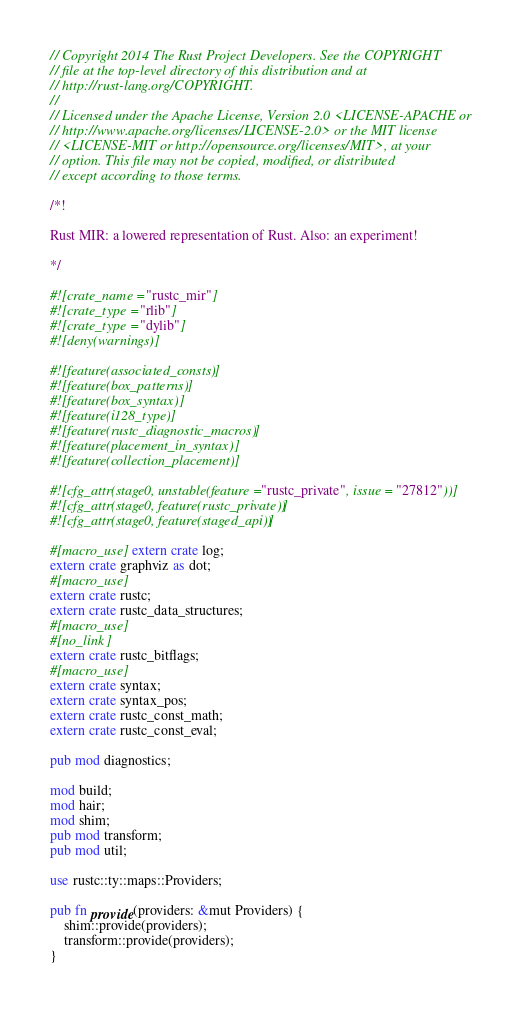Convert code to text. <code><loc_0><loc_0><loc_500><loc_500><_Rust_>// Copyright 2014 The Rust Project Developers. See the COPYRIGHT
// file at the top-level directory of this distribution and at
// http://rust-lang.org/COPYRIGHT.
//
// Licensed under the Apache License, Version 2.0 <LICENSE-APACHE or
// http://www.apache.org/licenses/LICENSE-2.0> or the MIT license
// <LICENSE-MIT or http://opensource.org/licenses/MIT>, at your
// option. This file may not be copied, modified, or distributed
// except according to those terms.

/*!

Rust MIR: a lowered representation of Rust. Also: an experiment!

*/

#![crate_name = "rustc_mir"]
#![crate_type = "rlib"]
#![crate_type = "dylib"]
#![deny(warnings)]

#![feature(associated_consts)]
#![feature(box_patterns)]
#![feature(box_syntax)]
#![feature(i128_type)]
#![feature(rustc_diagnostic_macros)]
#![feature(placement_in_syntax)]
#![feature(collection_placement)]

#![cfg_attr(stage0, unstable(feature = "rustc_private", issue = "27812"))]
#![cfg_attr(stage0, feature(rustc_private))]
#![cfg_attr(stage0, feature(staged_api))]

#[macro_use] extern crate log;
extern crate graphviz as dot;
#[macro_use]
extern crate rustc;
extern crate rustc_data_structures;
#[macro_use]
#[no_link]
extern crate rustc_bitflags;
#[macro_use]
extern crate syntax;
extern crate syntax_pos;
extern crate rustc_const_math;
extern crate rustc_const_eval;

pub mod diagnostics;

mod build;
mod hair;
mod shim;
pub mod transform;
pub mod util;

use rustc::ty::maps::Providers;

pub fn provide(providers: &mut Providers) {
    shim::provide(providers);
    transform::provide(providers);
}
</code> 